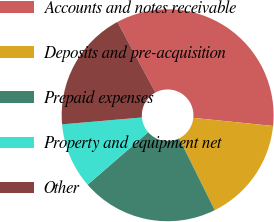Convert chart to OTSL. <chart><loc_0><loc_0><loc_500><loc_500><pie_chart><fcel>Accounts and notes receivable<fcel>Deposits and pre-acquisition<fcel>Prepaid expenses<fcel>Property and equipment net<fcel>Other<nl><fcel>34.47%<fcel>16.06%<fcel>20.95%<fcel>10.01%<fcel>18.51%<nl></chart> 